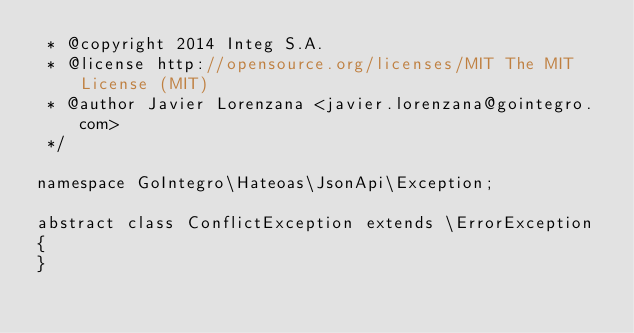Convert code to text. <code><loc_0><loc_0><loc_500><loc_500><_PHP_> * @copyright 2014 Integ S.A.
 * @license http://opensource.org/licenses/MIT The MIT License (MIT)
 * @author Javier Lorenzana <javier.lorenzana@gointegro.com>
 */

namespace GoIntegro\Hateoas\JsonApi\Exception;

abstract class ConflictException extends \ErrorException
{
}
</code> 